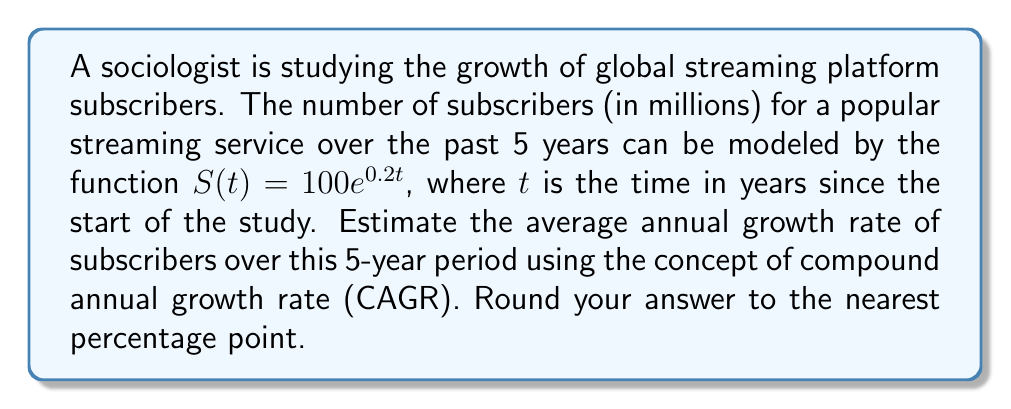Can you solve this math problem? To solve this problem, we'll follow these steps:

1) The compound annual growth rate (CAGR) is given by the formula:

   $$CAGR = \left(\frac{S(t_f)}{S(t_i)}\right)^{\frac{1}{t_f - t_i}} - 1$$

   where $S(t_f)$ is the final value, $S(t_i)$ is the initial value, and $(t_f - t_i)$ is the time period in years.

2) In our case, $t_i = 0$ and $t_f = 5$. Let's calculate $S(0)$ and $S(5)$:

   $S(0) = 100e^{0.2 \cdot 0} = 100$
   $S(5) = 100e^{0.2 \cdot 5} = 100e^1 \approx 271.83$

3) Now, let's plug these values into the CAGR formula:

   $$CAGR = \left(\frac{271.83}{100}\right)^{\frac{1}{5}} - 1$$

4) Simplify:
   
   $$CAGR = (2.7183)^{\frac{1}{5}} - 1$$

5) Calculate:
   
   $$CAGR = 1.2214 - 1 = 0.2214$$

6) Convert to a percentage and round to the nearest percentage point:
   
   $0.2214 \times 100 \approx 22\%$
Answer: 22% 